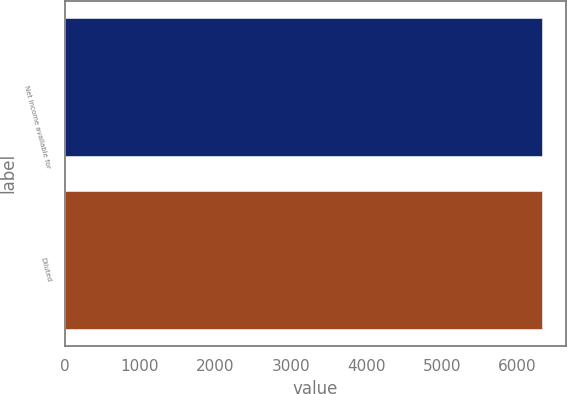Convert chart. <chart><loc_0><loc_0><loc_500><loc_500><bar_chart><fcel>Net income available for<fcel>Diluted<nl><fcel>6323<fcel>6329<nl></chart> 